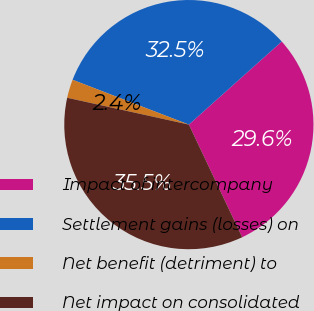Convert chart. <chart><loc_0><loc_0><loc_500><loc_500><pie_chart><fcel>Impact of intercompany<fcel>Settlement gains (losses) on<fcel>Net benefit (detriment) to<fcel>Net impact on consolidated<nl><fcel>29.58%<fcel>32.53%<fcel>2.4%<fcel>35.49%<nl></chart> 